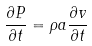Convert formula to latex. <formula><loc_0><loc_0><loc_500><loc_500>\frac { \partial P } { \partial t } = \rho a \frac { \partial v } { \partial t }</formula> 